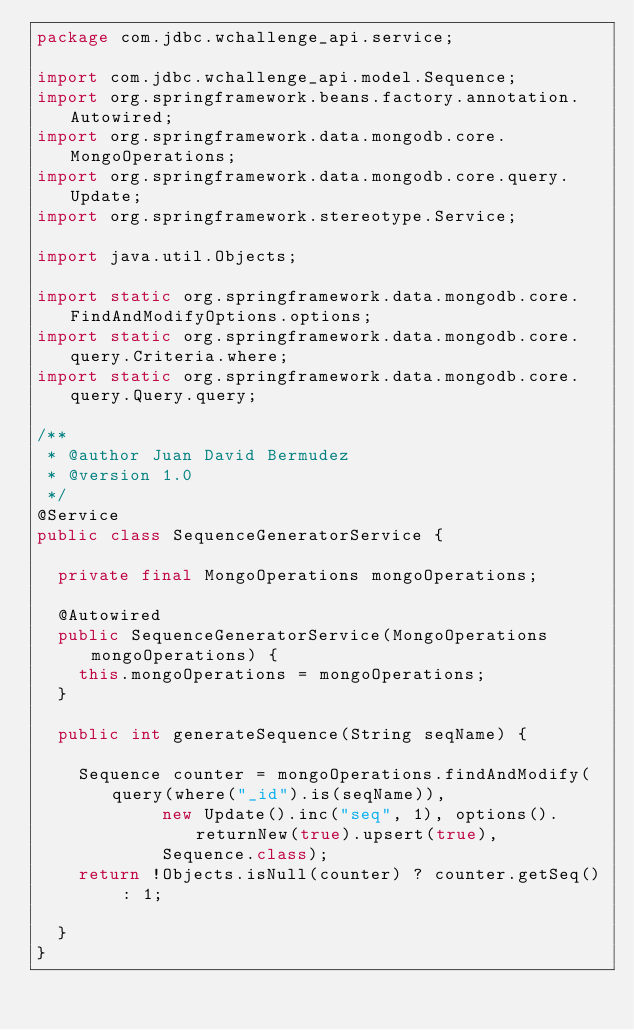Convert code to text. <code><loc_0><loc_0><loc_500><loc_500><_Java_>package com.jdbc.wchallenge_api.service;

import com.jdbc.wchallenge_api.model.Sequence;
import org.springframework.beans.factory.annotation.Autowired;
import org.springframework.data.mongodb.core.MongoOperations;
import org.springframework.data.mongodb.core.query.Update;
import org.springframework.stereotype.Service;

import java.util.Objects;

import static org.springframework.data.mongodb.core.FindAndModifyOptions.options;
import static org.springframework.data.mongodb.core.query.Criteria.where;
import static org.springframework.data.mongodb.core.query.Query.query;

/**
 * @author Juan David Bermudez
 * @version 1.0
 */
@Service
public class SequenceGeneratorService {

  private final MongoOperations mongoOperations;

  @Autowired
  public SequenceGeneratorService(MongoOperations mongoOperations) {
    this.mongoOperations = mongoOperations;
  }

  public int generateSequence(String seqName) {

    Sequence counter = mongoOperations.findAndModify(query(where("_id").is(seqName)),
            new Update().inc("seq", 1), options().returnNew(true).upsert(true),
            Sequence.class);
    return !Objects.isNull(counter) ? counter.getSeq() : 1;

  }
}
</code> 